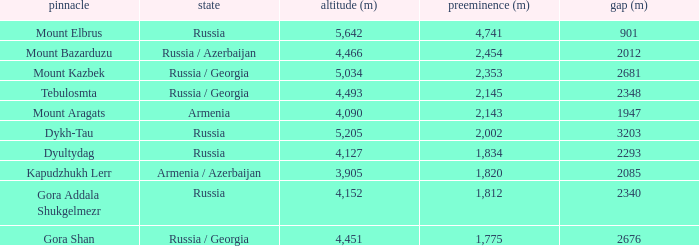What is the Elevation (m) of the Peak with a Prominence (m) larger than 2,143 and Col (m) of 2012? 4466.0. 